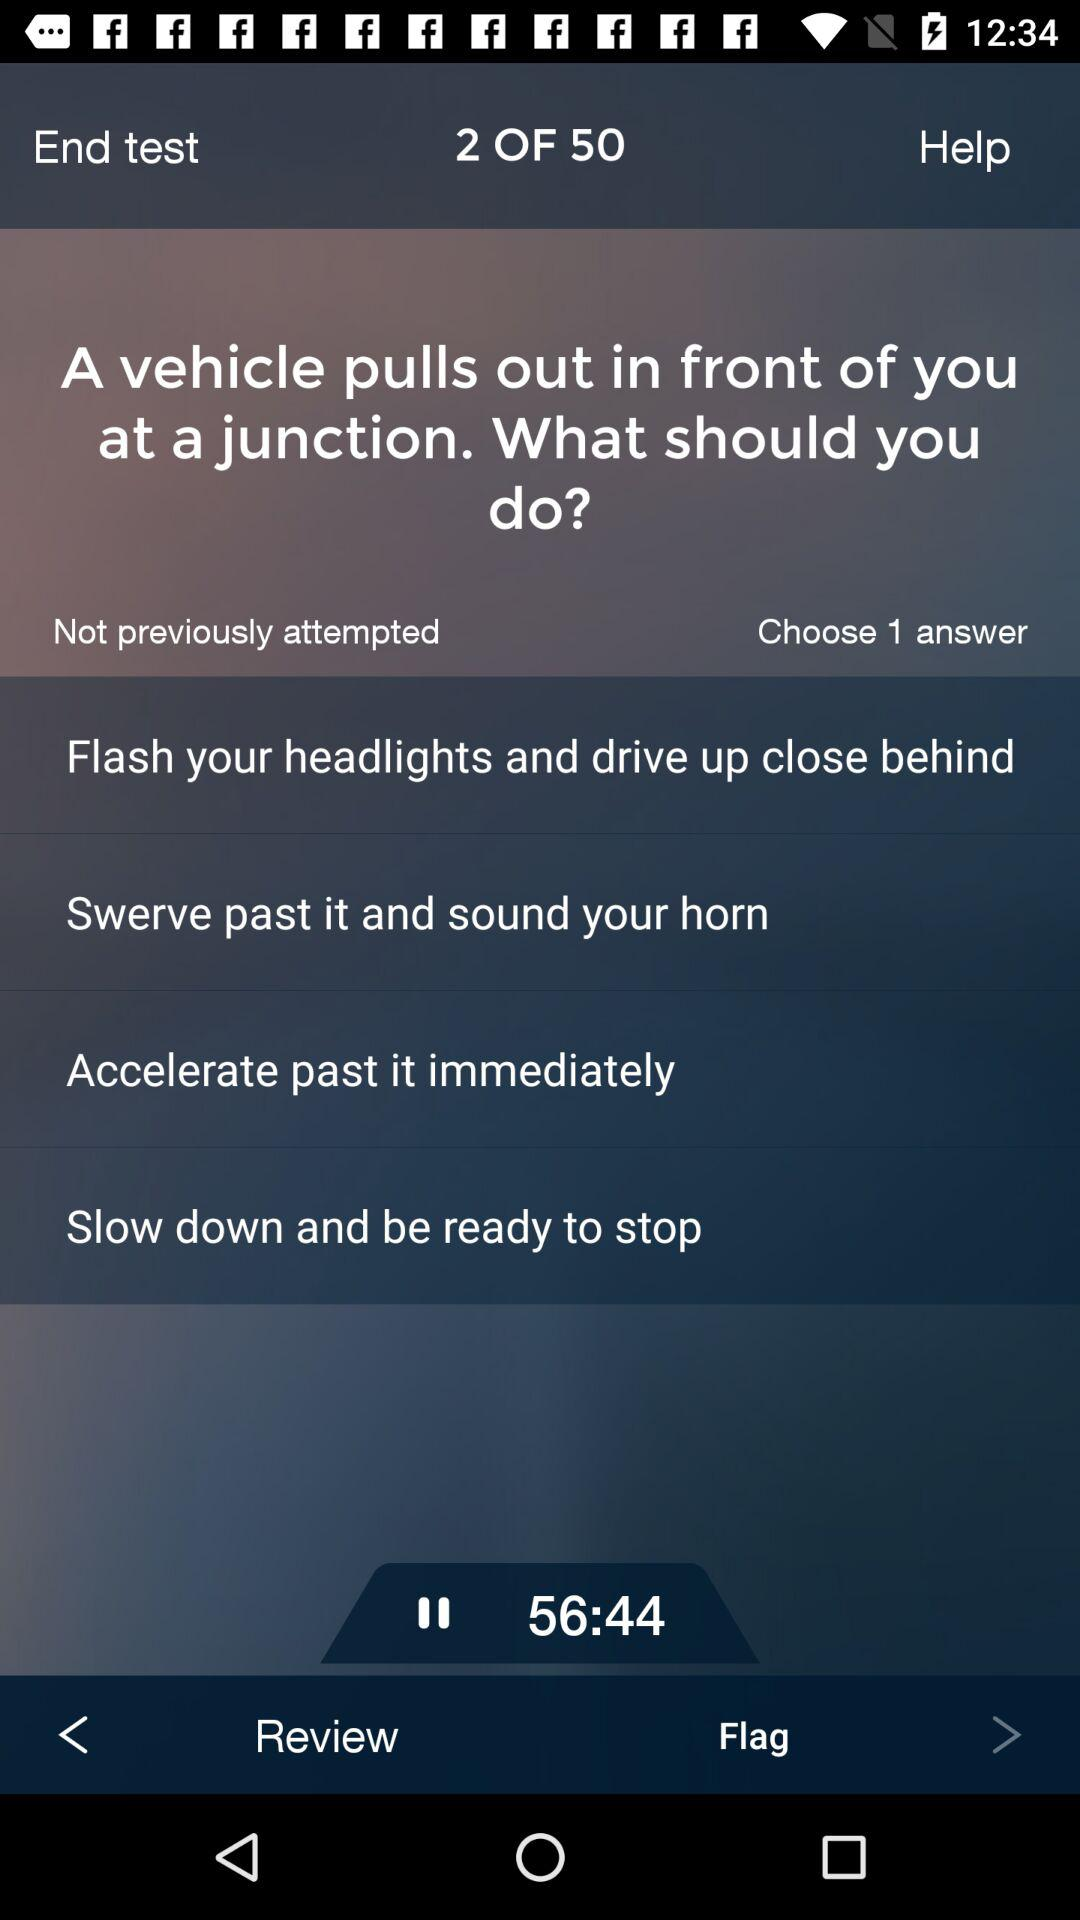How much time is allowed to complete one answer?
When the provided information is insufficient, respond with <no answer>. <no answer> 